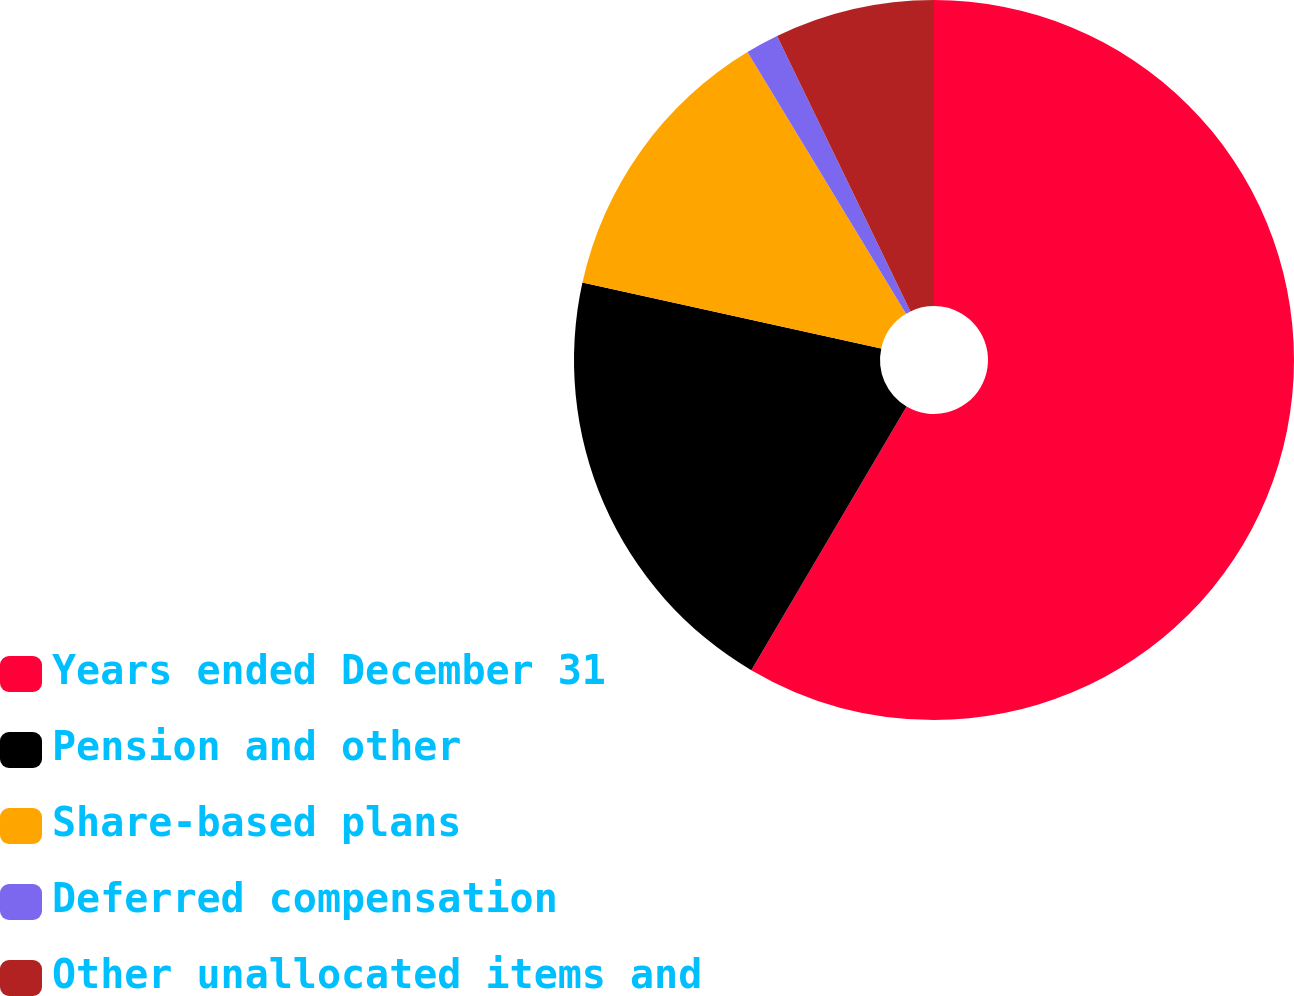Convert chart to OTSL. <chart><loc_0><loc_0><loc_500><loc_500><pie_chart><fcel>Years ended December 31<fcel>Pension and other<fcel>Share-based plans<fcel>Deferred compensation<fcel>Other unallocated items and<nl><fcel>58.47%<fcel>19.98%<fcel>12.88%<fcel>1.49%<fcel>7.18%<nl></chart> 